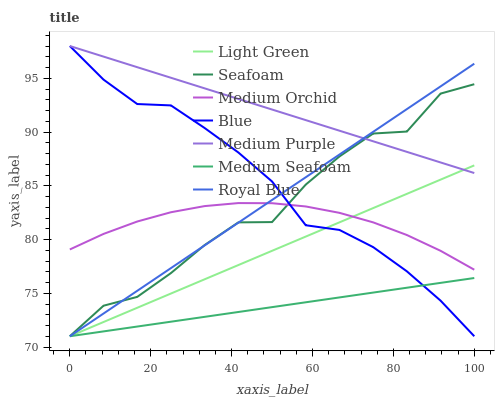Does Medium Seafoam have the minimum area under the curve?
Answer yes or no. Yes. Does Medium Purple have the maximum area under the curve?
Answer yes or no. Yes. Does Medium Orchid have the minimum area under the curve?
Answer yes or no. No. Does Medium Orchid have the maximum area under the curve?
Answer yes or no. No. Is Light Green the smoothest?
Answer yes or no. Yes. Is Seafoam the roughest?
Answer yes or no. Yes. Is Medium Orchid the smoothest?
Answer yes or no. No. Is Medium Orchid the roughest?
Answer yes or no. No. Does Blue have the lowest value?
Answer yes or no. Yes. Does Medium Orchid have the lowest value?
Answer yes or no. No. Does Medium Purple have the highest value?
Answer yes or no. Yes. Does Medium Orchid have the highest value?
Answer yes or no. No. Is Medium Seafoam less than Medium Purple?
Answer yes or no. Yes. Is Medium Purple greater than Medium Orchid?
Answer yes or no. Yes. Does Medium Orchid intersect Seafoam?
Answer yes or no. Yes. Is Medium Orchid less than Seafoam?
Answer yes or no. No. Is Medium Orchid greater than Seafoam?
Answer yes or no. No. Does Medium Seafoam intersect Medium Purple?
Answer yes or no. No. 